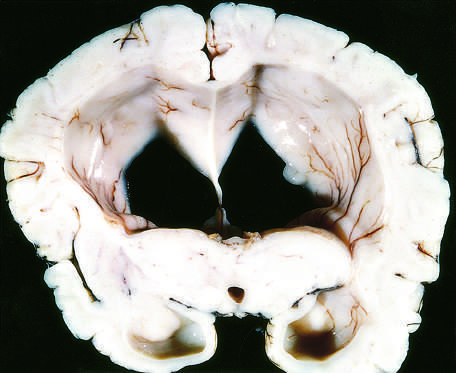what are flattened as a result of compression of the expanding brain by the dura mater and inner surface of the skull?
Answer the question using a single word or phrase. The surfaces of the gyri 